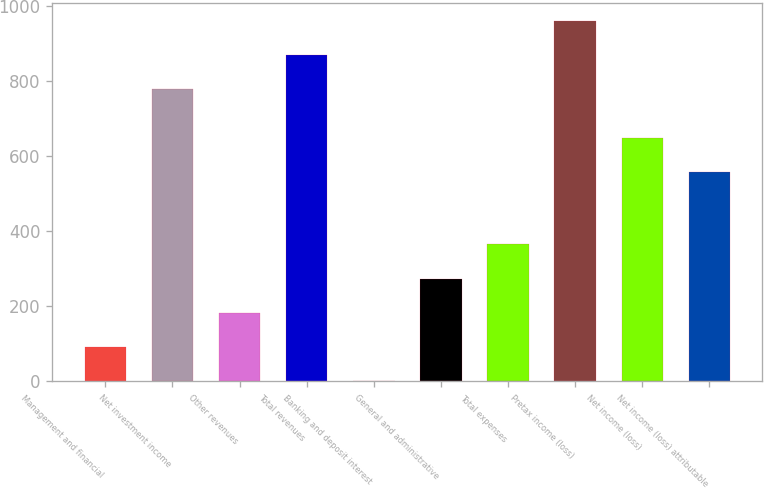Convert chart to OTSL. <chart><loc_0><loc_0><loc_500><loc_500><bar_chart><fcel>Management and financial<fcel>Net investment income<fcel>Other revenues<fcel>Total revenues<fcel>Banking and deposit interest<fcel>General and administrative<fcel>Total expenses<fcel>Pretax income (loss)<fcel>Net income (loss)<fcel>Net income (loss) attributable<nl><fcel>91.9<fcel>777<fcel>182.8<fcel>867.9<fcel>1<fcel>273.7<fcel>364.6<fcel>958.8<fcel>646.9<fcel>556<nl></chart> 